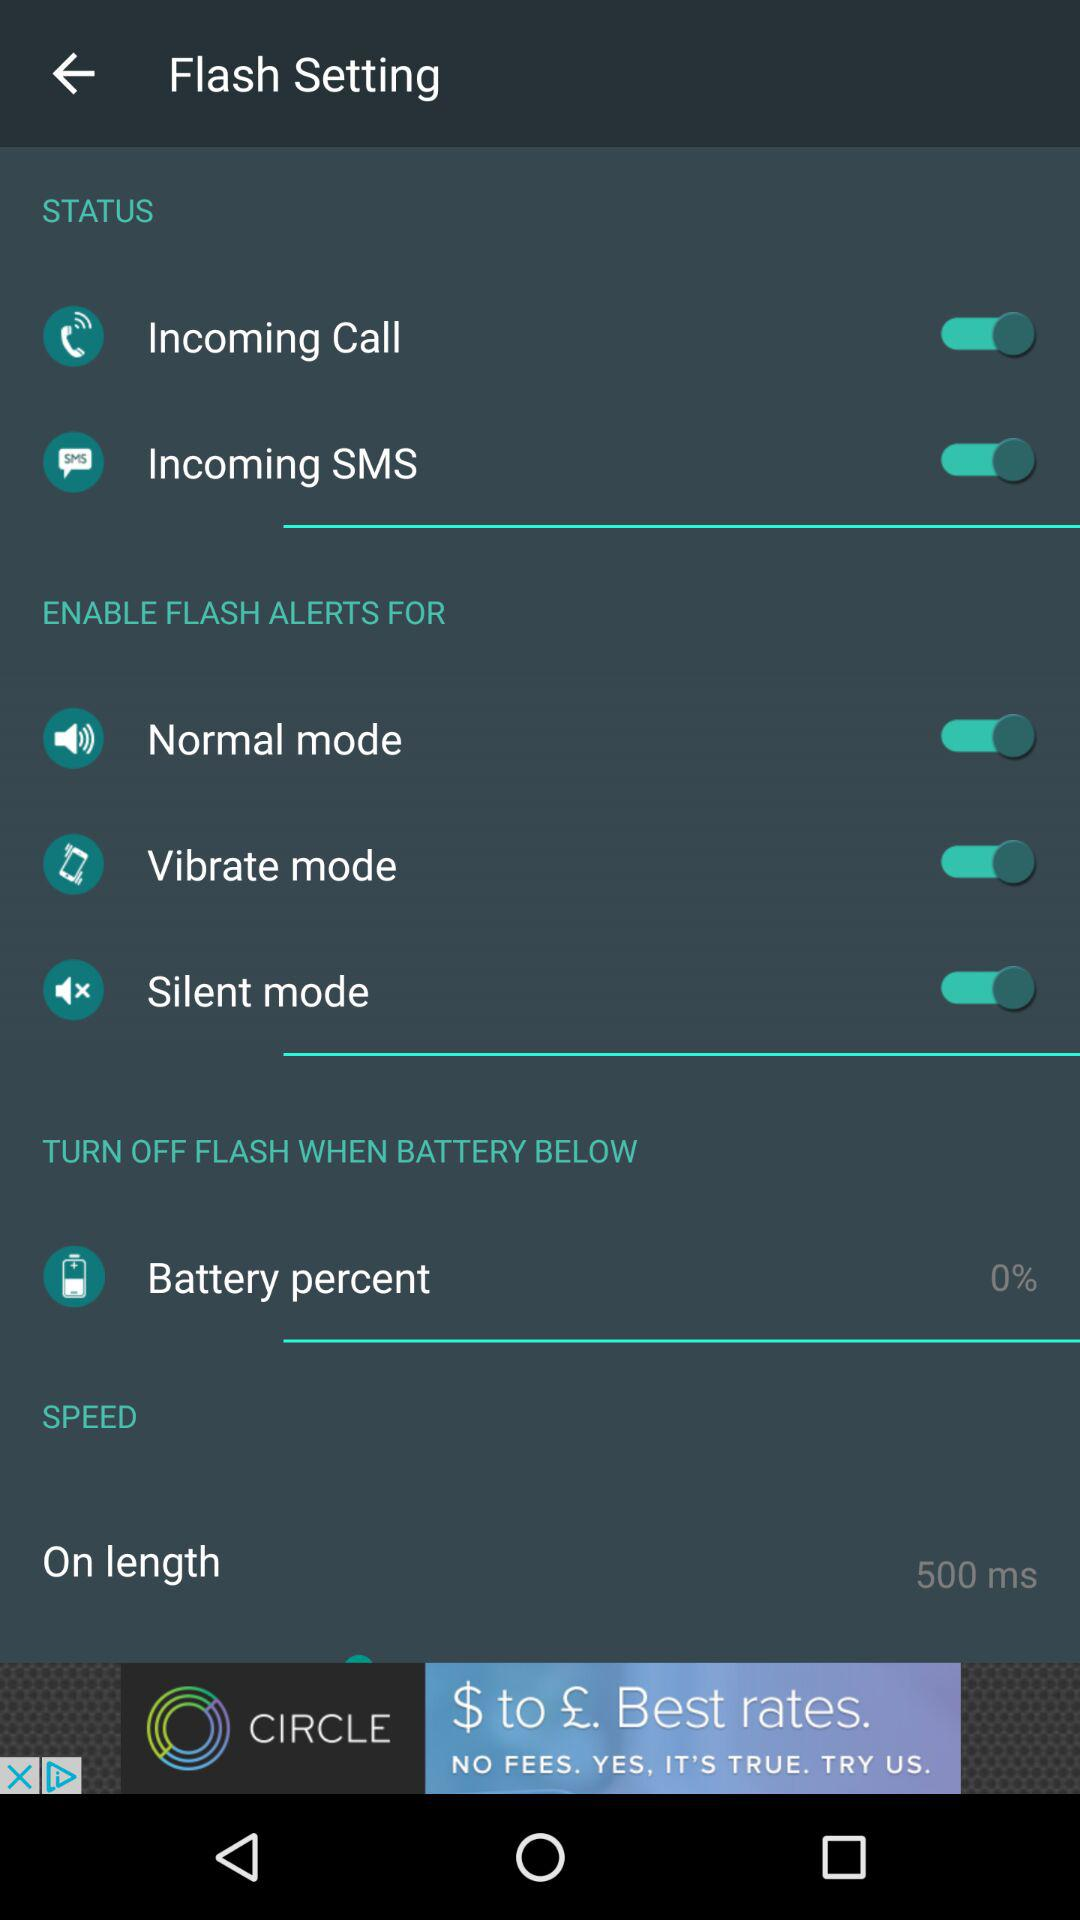What is the status of "Incoming Call"? The status of "Incoming Call" is "on". 